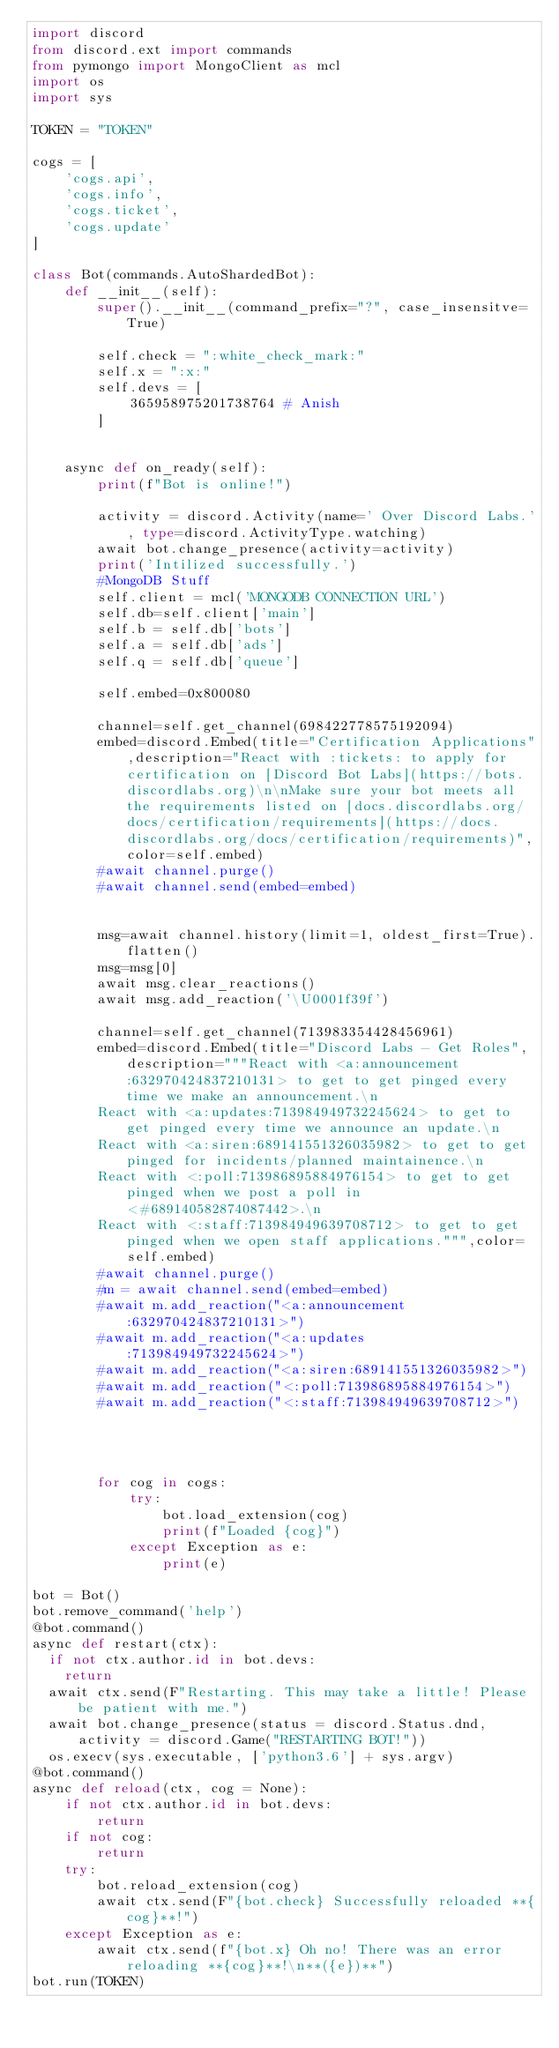<code> <loc_0><loc_0><loc_500><loc_500><_Python_>import discord
from discord.ext import commands 
from pymongo import MongoClient as mcl 
import os 
import sys

TOKEN = "TOKEN"

cogs = [
    'cogs.api',
    'cogs.info',
    'cogs.ticket',
    'cogs.update'
]

class Bot(commands.AutoShardedBot):
    def __init__(self):
        super().__init__(command_prefix="?", case_insensitve=True)

        self.check = ":white_check_mark:"
        self.x = ":x:"
        self.devs = [
            365958975201738764 # Anish
        ]
        

    async def on_ready(self):
        print(f"Bot is online!")

        activity = discord.Activity(name=' Over Discord Labs.', type=discord.ActivityType.watching)
        await bot.change_presence(activity=activity)
        print('Intilized successfully.')
        #MongoDB Stuff
        self.client = mcl('MONGODB CONNECTION URL')
        self.db=self.client['main']
        self.b = self.db['bots']
        self.a = self.db['ads']
        self.q = self.db['queue']

        self.embed=0x800080

        channel=self.get_channel(698422778575192094)
        embed=discord.Embed(title="Certification Applications",description="React with :tickets: to apply for certification on [Discord Bot Labs](https://bots.discordlabs.org)\n\nMake sure your bot meets all the requirements listed on [docs.discordlabs.org/docs/certification/requirements](https://docs.discordlabs.org/docs/certification/requirements)",color=self.embed)
        #await channel.purge()
        #await channel.send(embed=embed)

        
        msg=await channel.history(limit=1, oldest_first=True).flatten()
        msg=msg[0]
        await msg.clear_reactions()
        await msg.add_reaction('\U0001f39f')  

        channel=self.get_channel(713983354428456961)
        embed=discord.Embed(title="Discord Labs - Get Roles",description="""React with <a:announcement:632970424837210131> to get to get pinged every time we make an announcement.\n
        React with <a:updates:713984949732245624> to get to get pinged every time we announce an update.\n
        React with <a:siren:689141551326035982> to get to get pinged for incidents/planned maintainence.\n
        React with <:poll:713986895884976154> to get to get pinged when we post a poll in <#689140582874087442>.\n
        React with <:staff:713984949639708712> to get to get pinged when we open staff applications.""",color=self.embed)
        #await channel.purge()
        #m = await channel.send(embed=embed)
        #await m.add_reaction("<a:announcement:632970424837210131>")
        #await m.add_reaction("<a:updates:713984949732245624>")
        #await m.add_reaction("<a:siren:689141551326035982>")
        #await m.add_reaction("<:poll:713986895884976154>")
        #await m.add_reaction("<:staff:713984949639708712>")
    



        for cog in cogs:
            try:
                bot.load_extension(cog)
                print(f"Loaded {cog}")
            except Exception as e:
                print(e)

bot = Bot()
bot.remove_command('help')
@bot.command()
async def restart(ctx):
  if not ctx.author.id in bot.devs:
    return
  await ctx.send(F"Restarting. This may take a little! Please be patient with me.")
  await bot.change_presence(status = discord.Status.dnd, activity = discord.Game("RESTARTING BOT!"))
  os.execv(sys.executable, ['python3.6'] + sys.argv)
@bot.command()
async def reload(ctx, cog = None):
    if not ctx.author.id in bot.devs:
        return
    if not cog:
        return
    try:
        bot.reload_extension(cog)
        await ctx.send(F"{bot.check} Successfully reloaded **{cog}**!")
    except Exception as e:
        await ctx.send(f"{bot.x} Oh no! There was an error reloading **{cog}**!\n**({e})**")
bot.run(TOKEN)
</code> 